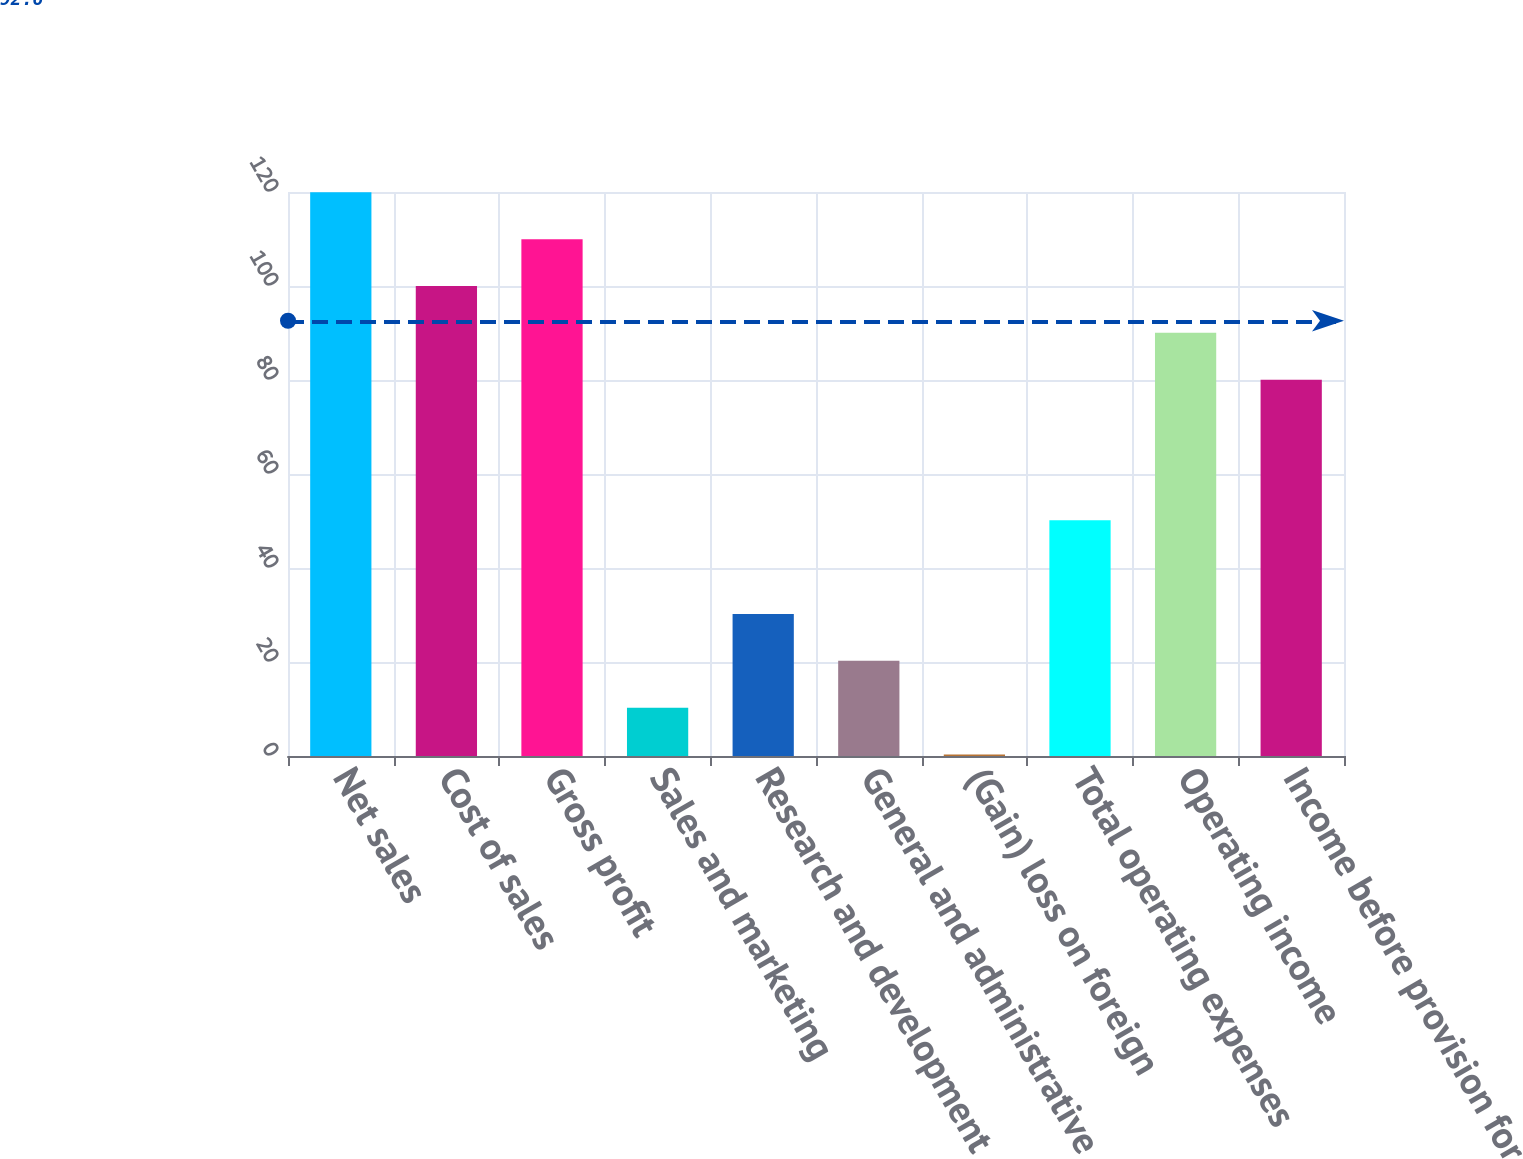Convert chart to OTSL. <chart><loc_0><loc_0><loc_500><loc_500><bar_chart><fcel>Net sales<fcel>Cost of sales<fcel>Gross profit<fcel>Sales and marketing<fcel>Research and development<fcel>General and administrative<fcel>(Gain) loss on foreign<fcel>Total operating expenses<fcel>Operating income<fcel>Income before provision for<nl><fcel>119.94<fcel>100<fcel>109.97<fcel>10.27<fcel>30.21<fcel>20.24<fcel>0.3<fcel>50.15<fcel>90.03<fcel>80.06<nl></chart> 